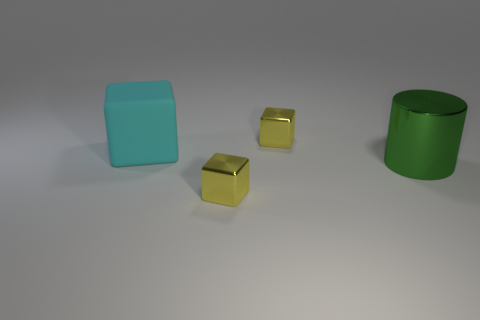What time of day does the lighting in the image suggest? The lighting in the image does not strongly suggest any particular time of day. It appears to be artificial lighting, likely from an indoor source, rather than natural sunlight. This is indicated by the soft shadows and the uniformity of the light's color and intensity. 